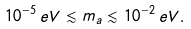Convert formula to latex. <formula><loc_0><loc_0><loc_500><loc_500>1 0 ^ { - 5 } \, e V \lesssim m _ { a } \lesssim 1 0 ^ { - 2 } \, e V .</formula> 